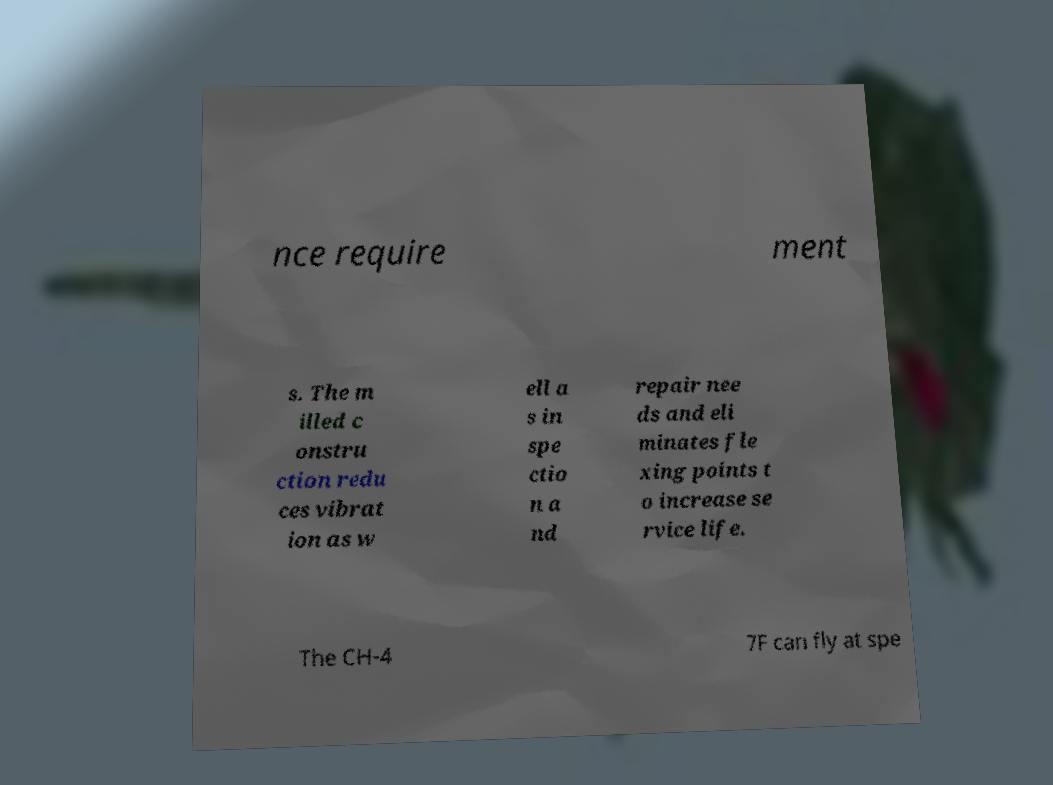Please read and relay the text visible in this image. What does it say? nce require ment s. The m illed c onstru ction redu ces vibrat ion as w ell a s in spe ctio n a nd repair nee ds and eli minates fle xing points t o increase se rvice life. The CH-4 7F can fly at spe 